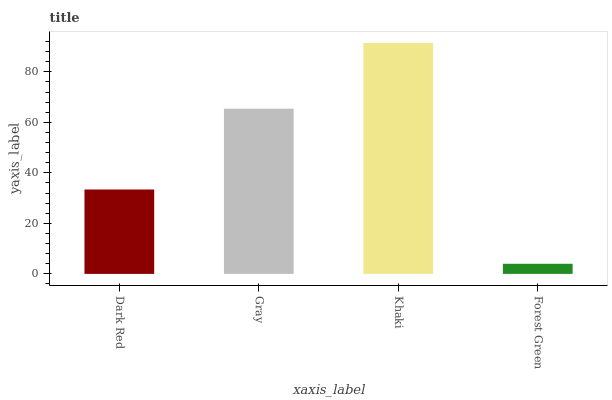Is Forest Green the minimum?
Answer yes or no. Yes. Is Khaki the maximum?
Answer yes or no. Yes. Is Gray the minimum?
Answer yes or no. No. Is Gray the maximum?
Answer yes or no. No. Is Gray greater than Dark Red?
Answer yes or no. Yes. Is Dark Red less than Gray?
Answer yes or no. Yes. Is Dark Red greater than Gray?
Answer yes or no. No. Is Gray less than Dark Red?
Answer yes or no. No. Is Gray the high median?
Answer yes or no. Yes. Is Dark Red the low median?
Answer yes or no. Yes. Is Khaki the high median?
Answer yes or no. No. Is Gray the low median?
Answer yes or no. No. 